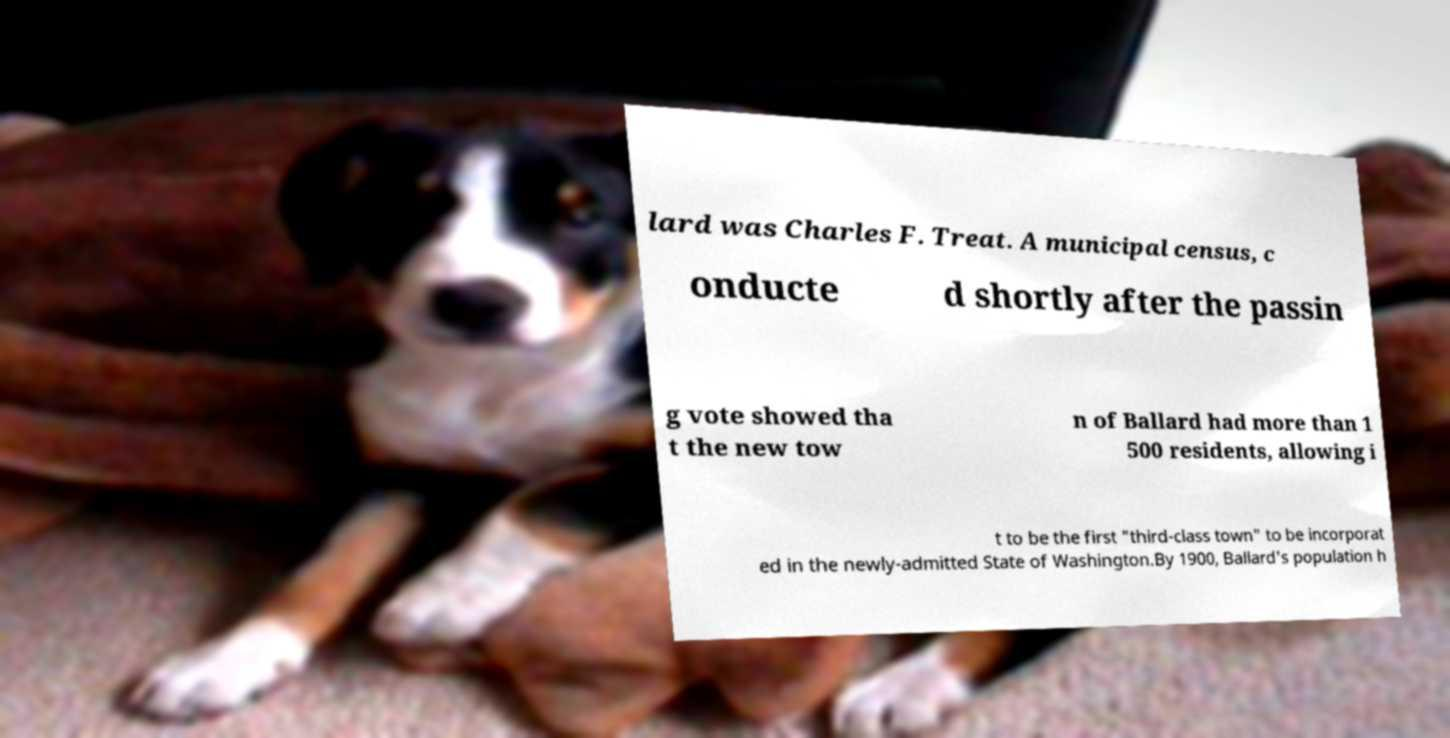For documentation purposes, I need the text within this image transcribed. Could you provide that? lard was Charles F. Treat. A municipal census, c onducte d shortly after the passin g vote showed tha t the new tow n of Ballard had more than 1 500 residents, allowing i t to be the first "third-class town" to be incorporat ed in the newly-admitted State of Washington.By 1900, Ballard's population h 